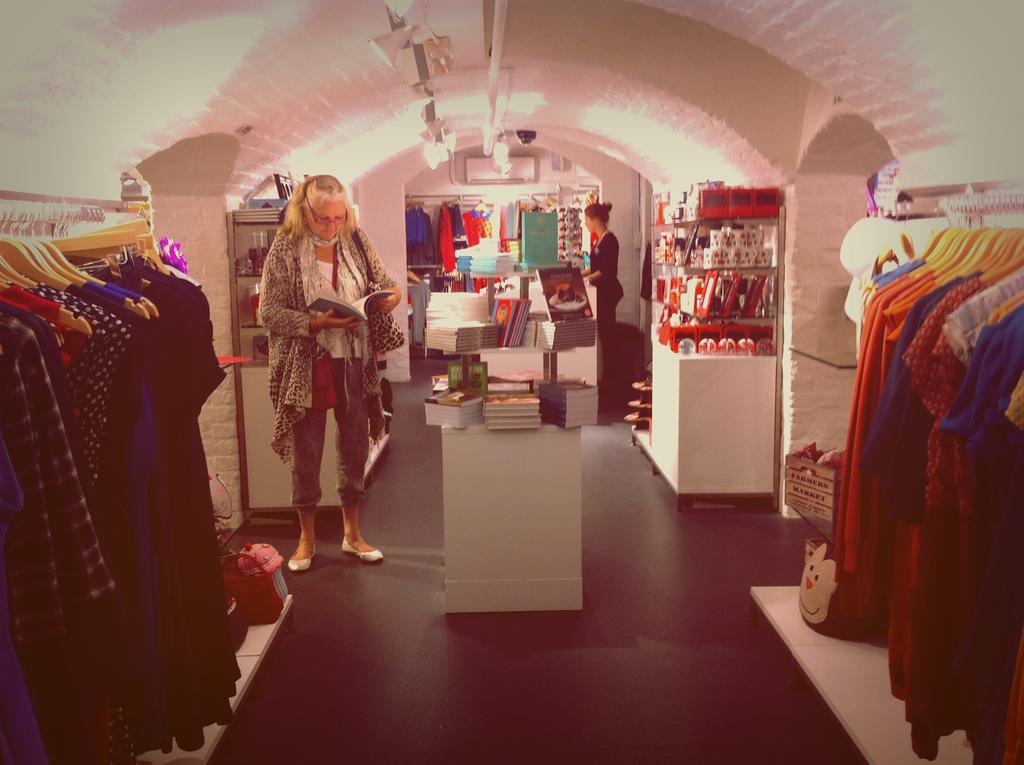Who is the main subject in the image? There is a woman in the image. What is the woman doing in the image? The woman is reading a book. What is the woman wearing in the image? The woman is wearing a dress. What else can be seen on the table in the image? There are books on a table in the image. What is present on either side of the image? There are dresses on either side of the image. What is visible at the top of the image? There are lights visible at the top of the image. What type of oven is visible in the image? There is no oven present in the image. How does the woman walk to the hospital in the image? The image does not depict the woman walking or any hospital; it shows her reading a book while wearing a dress. 